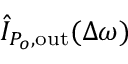<formula> <loc_0><loc_0><loc_500><loc_500>\hat { I } _ { P _ { o } , o u t } ( \Delta \omega )</formula> 